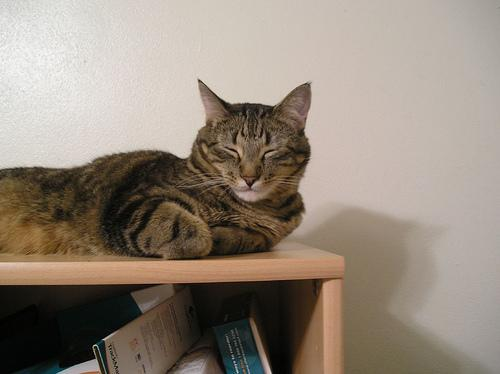What is the cat on top of?

Choices:
A) box
B) book shelf
C) refrigerator
D) dog book shelf 